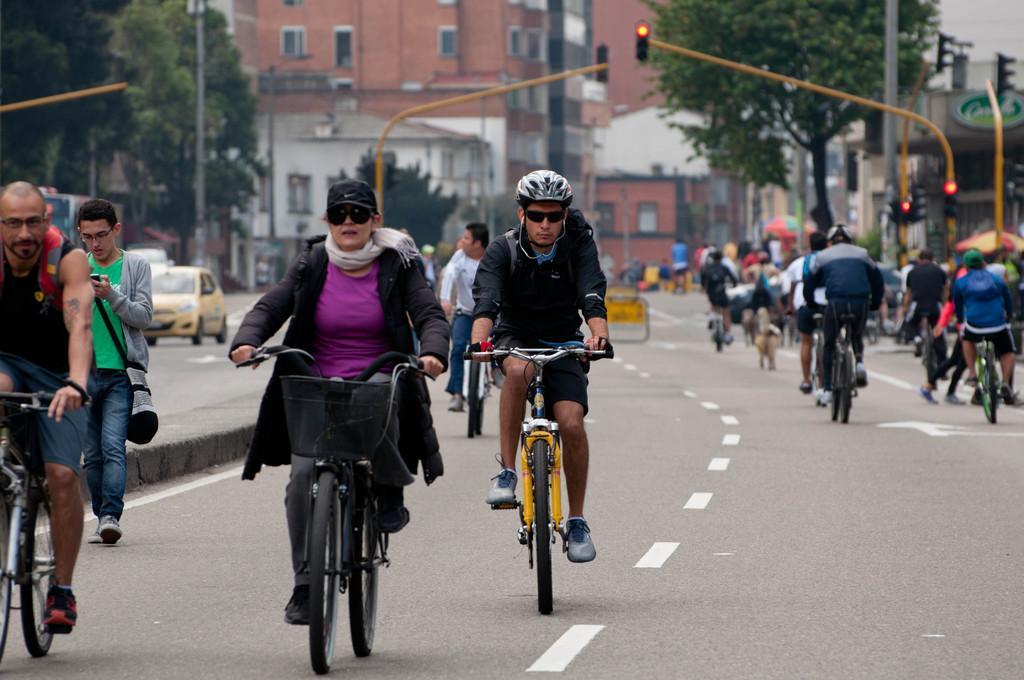Could you give a brief overview of what you see in this image? In this image I see number of people in which most of them are on the cycle and few of them are on the path. In the background I see the traffic signals, buildings and the trees. 